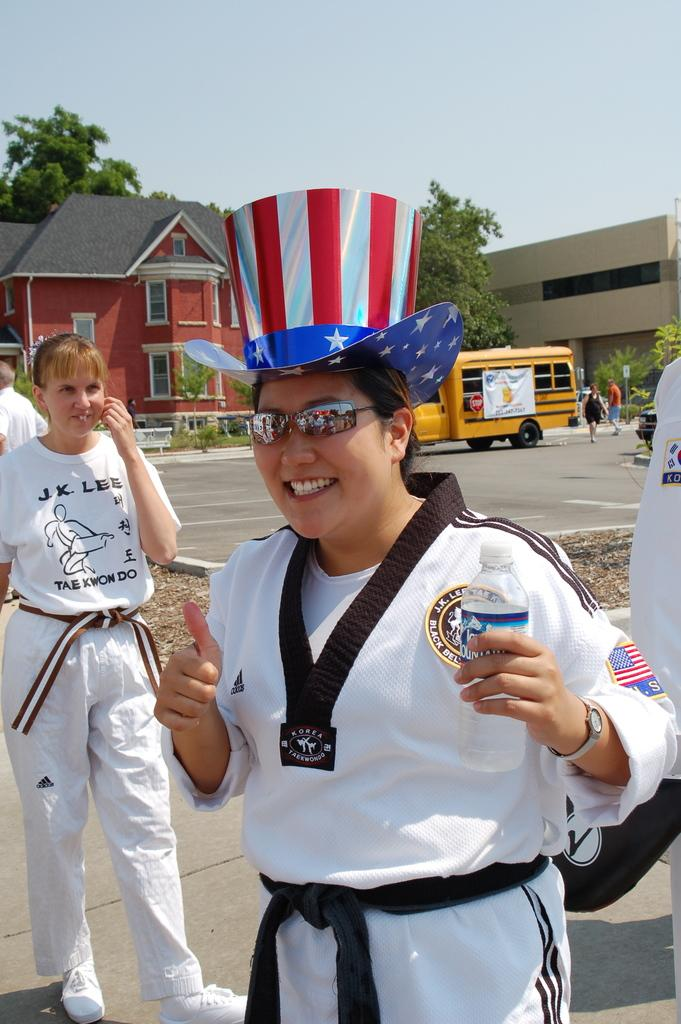<image>
Give a short and clear explanation of the subsequent image. A Tae Kwon Do practitioner wearing a red white and blue top hat smiling for the camera. 